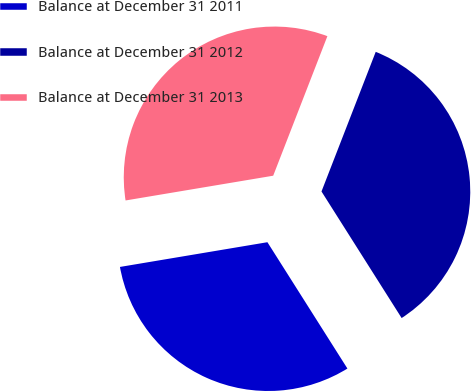Convert chart to OTSL. <chart><loc_0><loc_0><loc_500><loc_500><pie_chart><fcel>Balance at December 31 2011<fcel>Balance at December 31 2012<fcel>Balance at December 31 2013<nl><fcel>31.34%<fcel>35.12%<fcel>33.54%<nl></chart> 